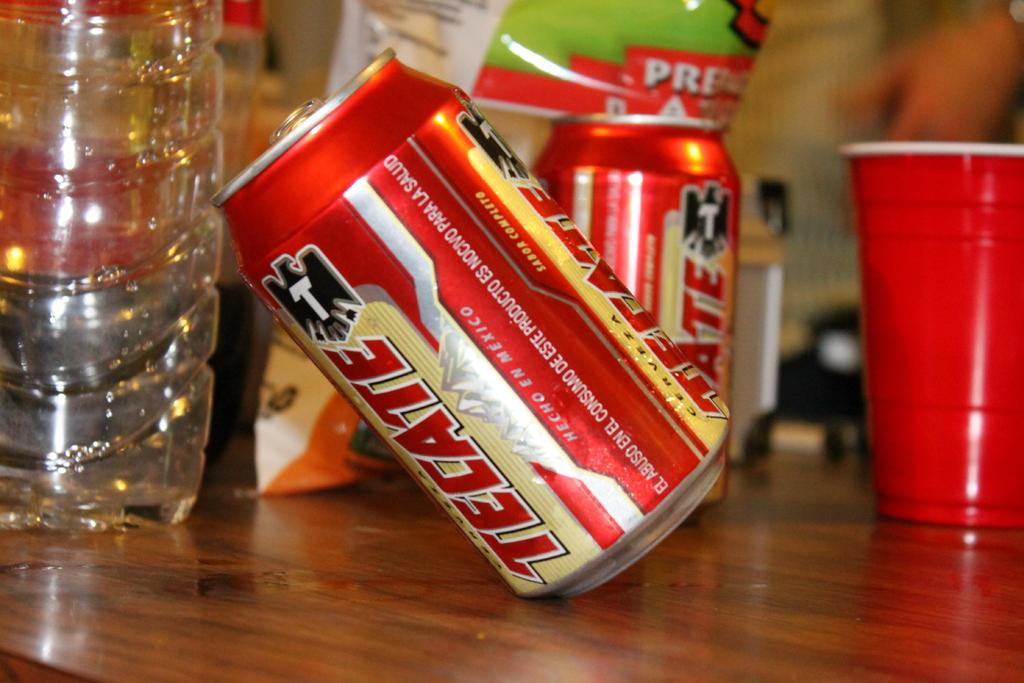<image>
Provide a brief description of the given image. Two cans of Tecate beer and a red cup are on a wooden table. 